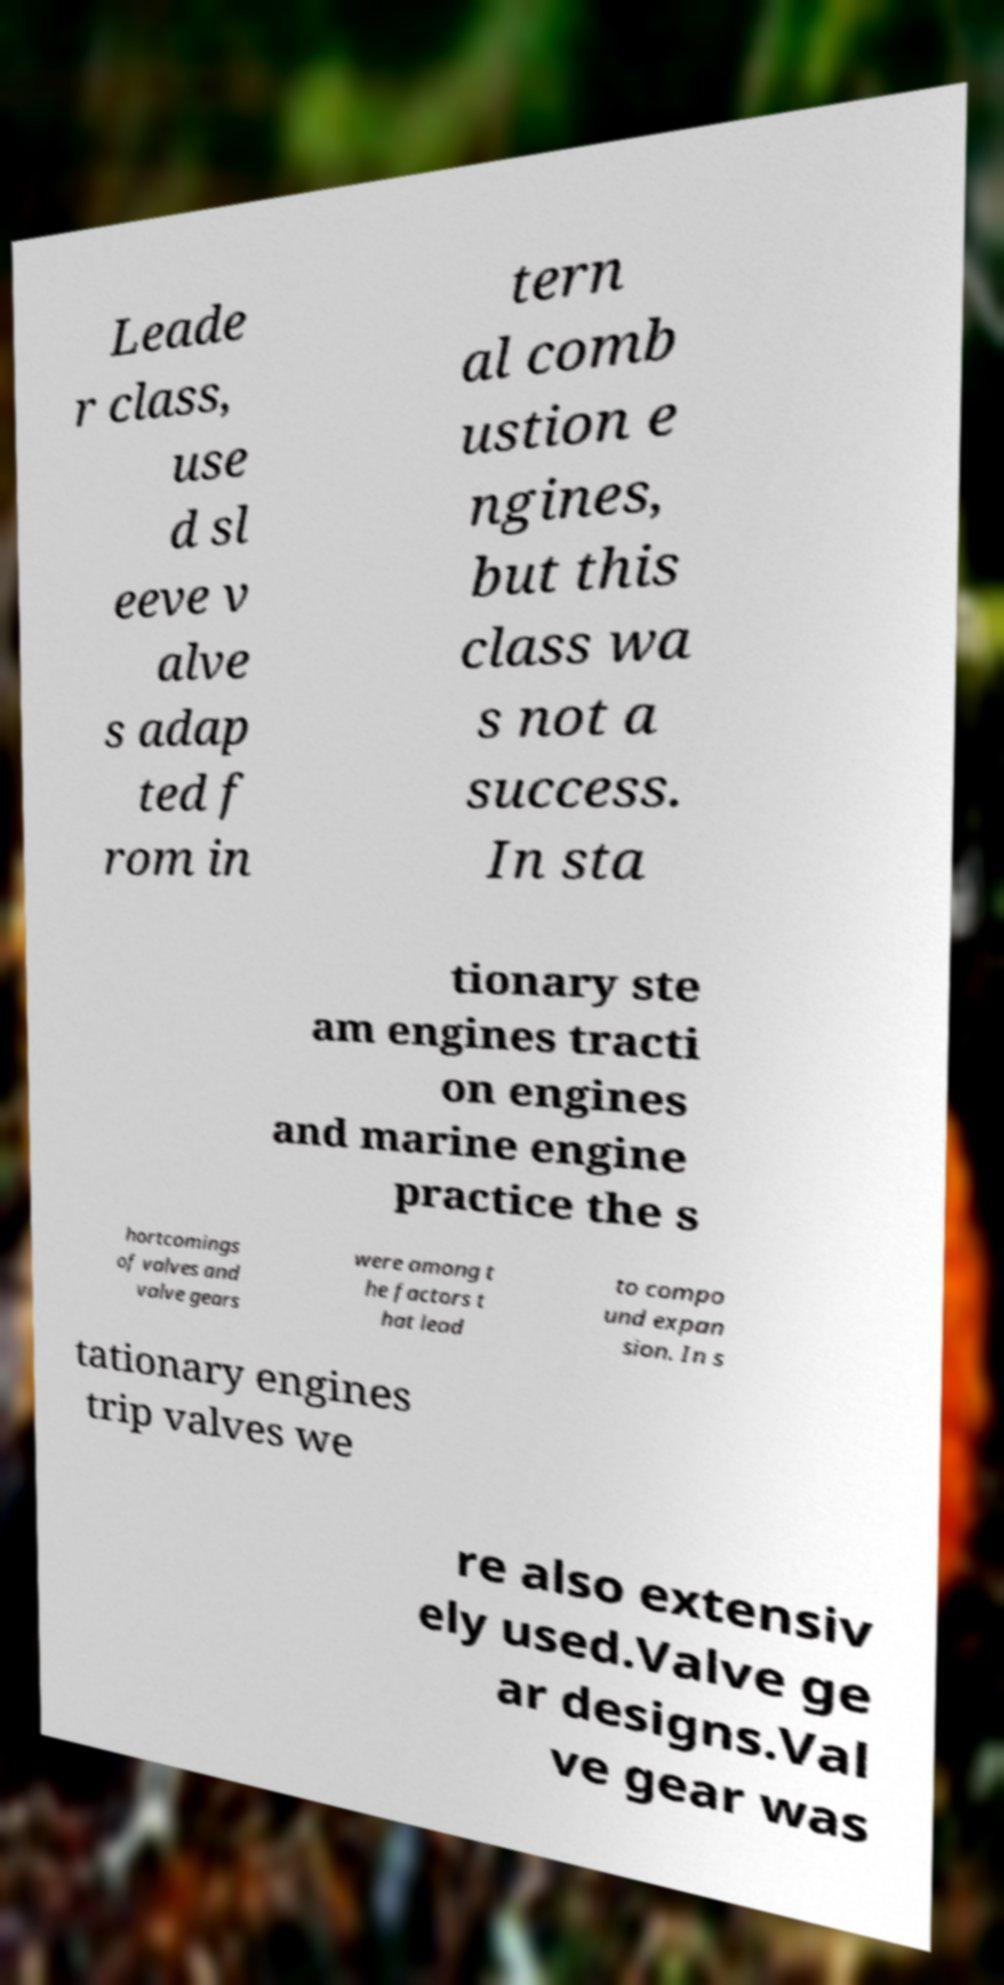I need the written content from this picture converted into text. Can you do that? Leade r class, use d sl eeve v alve s adap ted f rom in tern al comb ustion e ngines, but this class wa s not a success. In sta tionary ste am engines tracti on engines and marine engine practice the s hortcomings of valves and valve gears were among t he factors t hat lead to compo und expan sion. In s tationary engines trip valves we re also extensiv ely used.Valve ge ar designs.Val ve gear was 